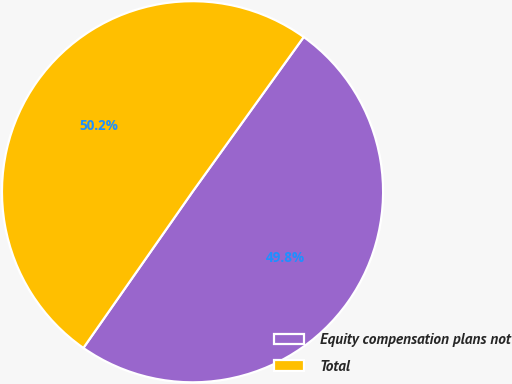Convert chart. <chart><loc_0><loc_0><loc_500><loc_500><pie_chart><fcel>Equity compensation plans not<fcel>Total<nl><fcel>49.79%<fcel>50.21%<nl></chart> 